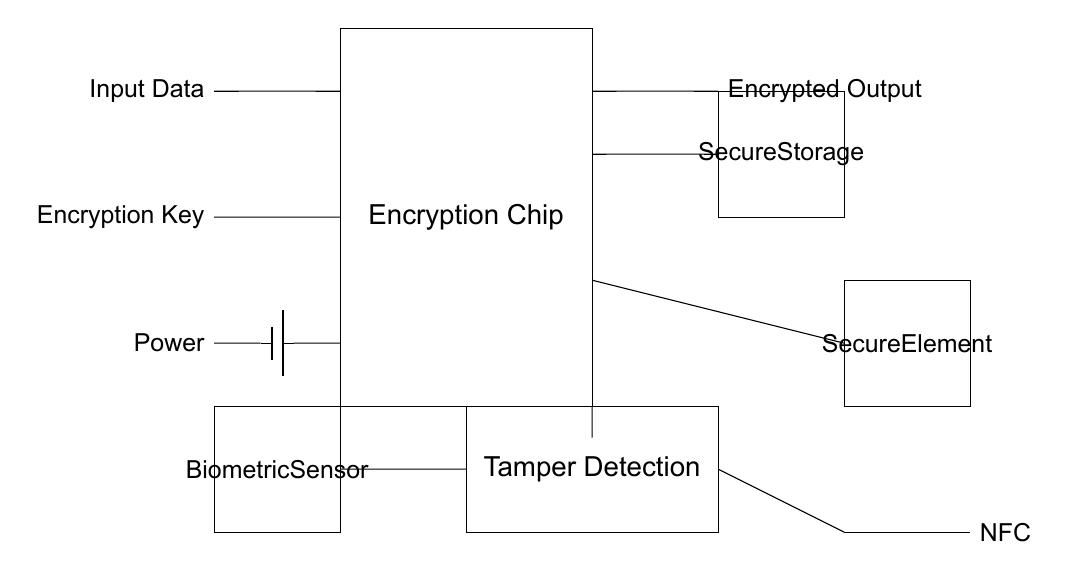What is the main component of the circuit? The main component is the Encryption Chip, which is designated as the central piece of the circuit and is responsible for processing the input data.
Answer: Encryption Chip What type of storage is included in the circuit? The circuit includes Secure Storage, which is specifically designed to keep sensitive data protected after encryption.
Answer: Secure Storage What is the function of the biometric sensor in this circuit? The Biometric Sensor is responsible for authentication before the encryption process can proceed, adding a layer of security by ensuring that only authorized users can encrypt or access data.
Answer: Authentication How does the tamper detection system operate? The Tamper Detection system monitors the circuit for any unauthorized access or alterations, which can trigger alerts or disable the encryption functionality to protect the data.
Answer: Monitors unauthorized access What type of communication does the circuit support? The circuit supports NFC communication, which allows for contactless data transfer and enhances the convenience of using the mobile device while still maintaining a level of security.
Answer: NFC Which component provides power to the circuit? The Power is supplied by a battery, ensuring that the circuit has the necessary energy to function while encrypting and processing data.
Answer: Battery 